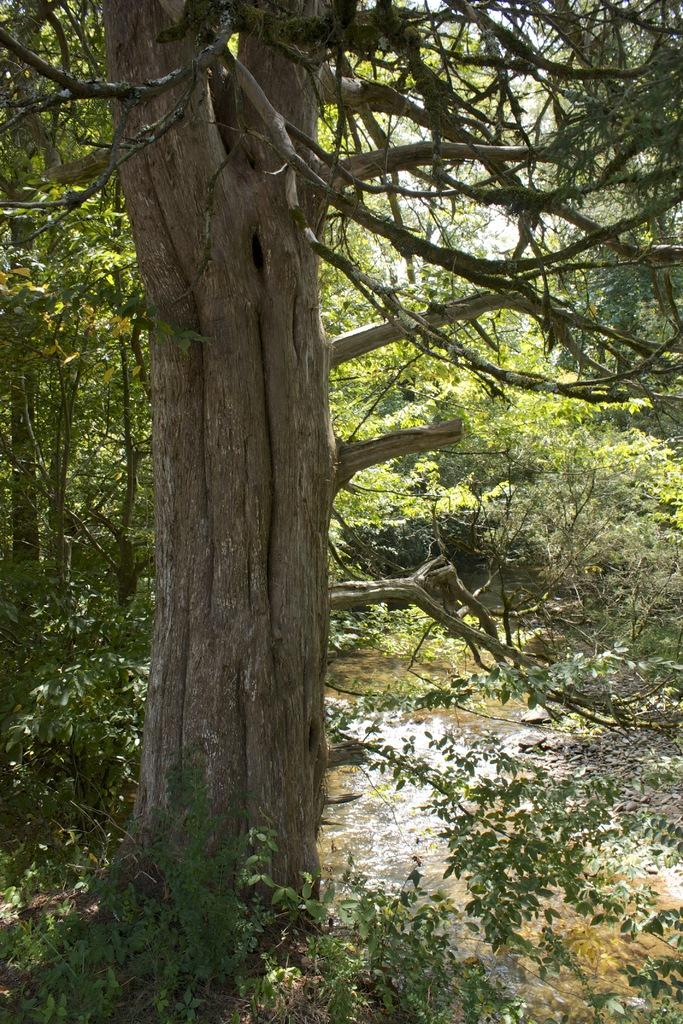What type of vegetation is on the left side of the image? There are trees on the left side of the image. What is visible at the bottom of the image? Water and the ground are visible at the bottom of the image. What is visible at the top of the image? The sky is visible at the top of the image. Where is the yak sitting on the desk in the image? There is no yak or desk present in the image. What type of fowl can be seen flying in the sky in the image? There are no birds or fowl visible in the sky in the image. 